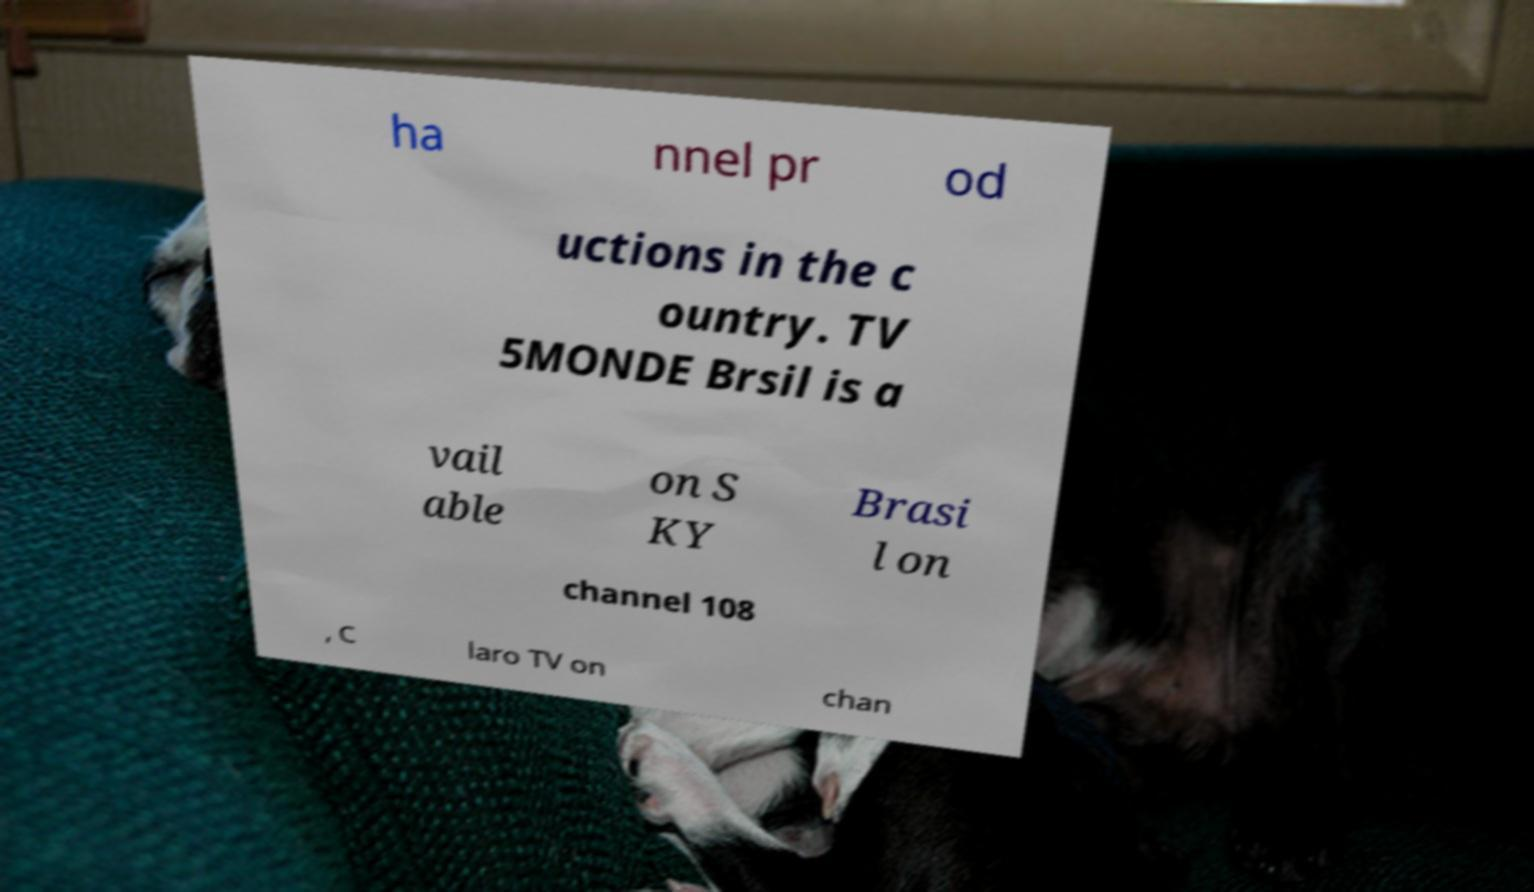What messages or text are displayed in this image? I need them in a readable, typed format. ha nnel pr od uctions in the c ountry. TV 5MONDE Brsil is a vail able on S KY Brasi l on channel 108 , C laro TV on chan 